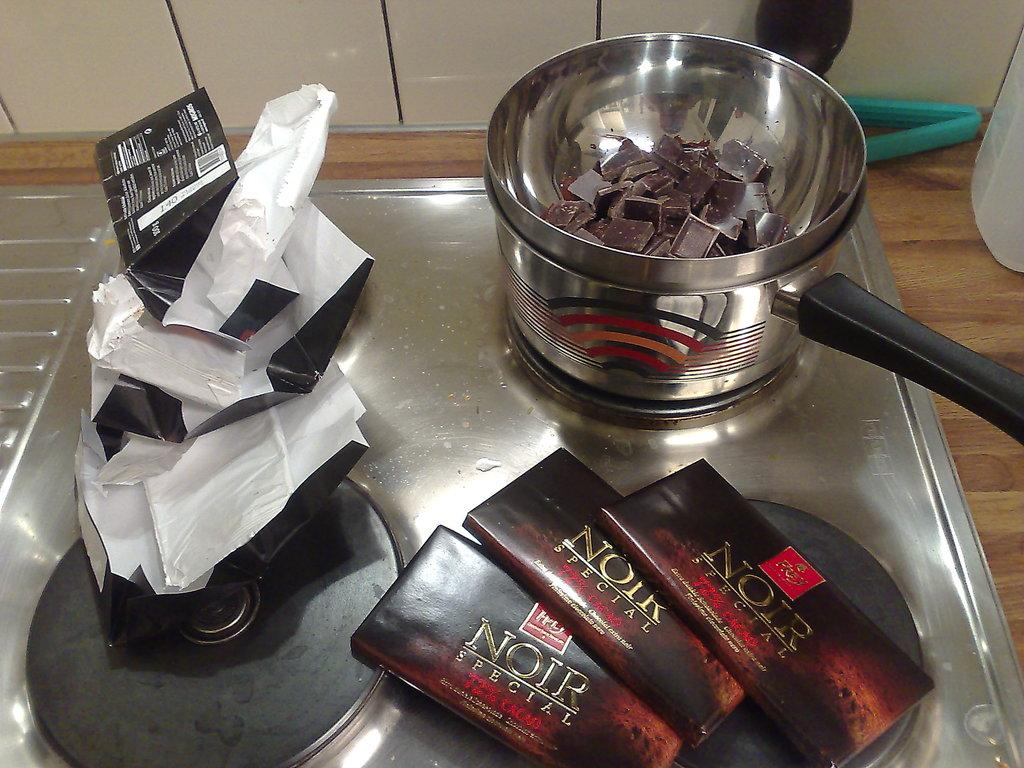Provide a one-sentence caption for the provided image. A pan melts a broken up bar of Noir chocolate. 